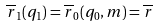<formula> <loc_0><loc_0><loc_500><loc_500>\overline { r } _ { 1 } ( q _ { 1 } ) = \overline { r } _ { 0 } ( q _ { 0 } , m ) = \overline { r }</formula> 